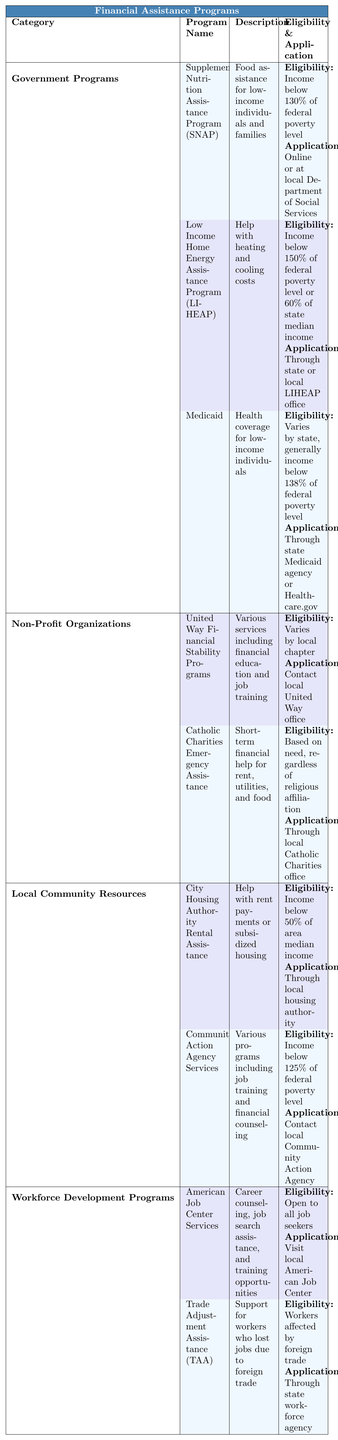What assistance does the Supplemental Nutrition Assistance Program (SNAP) provide? The table shows that SNAP provides food assistance for low-income individuals and families.
Answer: Food assistance What is the income eligibility for the Low Income Home Energy Assistance Program (LIHEAP)? According to the table, the income eligibility for LIHEAP is below 150% of federal poverty level or 60% of state median income.
Answer: Below 150% of federal poverty level or 60% of state median income Can anyone apply for Medicaid? The table indicates that the eligibility for Medicaid varies by state, generally requiring an income below 138% of the federal poverty level. This means not everyone can apply; only those who meet the income criteria can.
Answer: No Which organization offers financial education and job training? The table lists United Way Financial Stability Programs, which includes various services such as financial education and job training.
Answer: United Way Financial Stability Programs How many Government Programs are listed in the table? The table specifies three Government Programs: SNAP, LIHEAP, and Medicaid. Therefore, the total count is three.
Answer: Three Is Catholic Charities Emergency Assistance available to people regardless of their religious affiliation? The table states that Catholic Charities Emergency Assistance is based on need, regardless of religious affiliation, indicating it is available to all.
Answer: Yes What type of assistance does City Housing Authority Rental Assistance provide? The table mentions that City Housing Authority Rental Assistance helps with rent payments or subsidized housing.
Answer: Rent payments or subsidized housing Which category has the least number of programs listed? The Workforce Development Programs category lists two programs (American Job Center Services and Trade Adjustment Assistance), which is fewer than other categories.
Answer: Workforce Development Programs If a worker is affected by foreign trade, which program should they consider applying to? The table indicates that workers affected by foreign trade should consider applying to the Trade Adjustment Assistance (TAA) program.
Answer: Trade Adjustment Assistance (TAA) What is the common eligibility threshold for income among the local community resources? The table shows that the City Housing Authority Rental Assistance has an eligibility of income below 50% of area median income and Community Action Agency Services has an eligibility of income below 125% of federal poverty level. The common threshold is that both require being below a certain income level, but they are not the same.
Answer: Not the same 